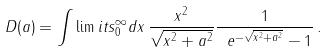<formula> <loc_0><loc_0><loc_500><loc_500>D ( a ) = \int \lim i t s _ { 0 } ^ { \infty } d x \, \frac { x ^ { 2 } } { \sqrt { x ^ { 2 } + a ^ { 2 } } } \frac { 1 } { \ e ^ { - \sqrt { x ^ { 2 } + a ^ { 2 } } } - 1 } \, .</formula> 